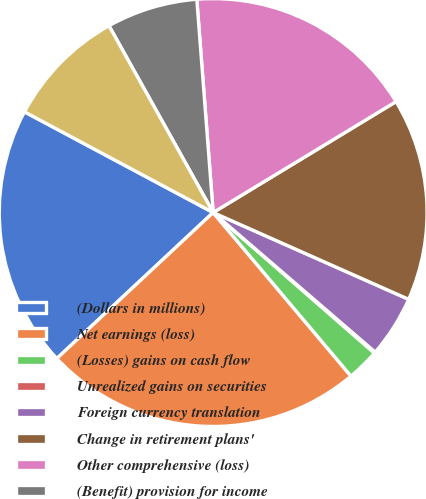Convert chart to OTSL. <chart><loc_0><loc_0><loc_500><loc_500><pie_chart><fcel>(Dollars in millions)<fcel>Net earnings (loss)<fcel>(Losses) gains on cash flow<fcel>Unrealized gains on securities<fcel>Foreign currency translation<fcel>Change in retirement plans'<fcel>Other comprehensive (loss)<fcel>(Benefit) provision for income<fcel>Comprehensive income (loss)<nl><fcel>19.76%<fcel>24.19%<fcel>2.45%<fcel>0.09%<fcel>4.67%<fcel>15.33%<fcel>17.54%<fcel>6.88%<fcel>9.1%<nl></chart> 